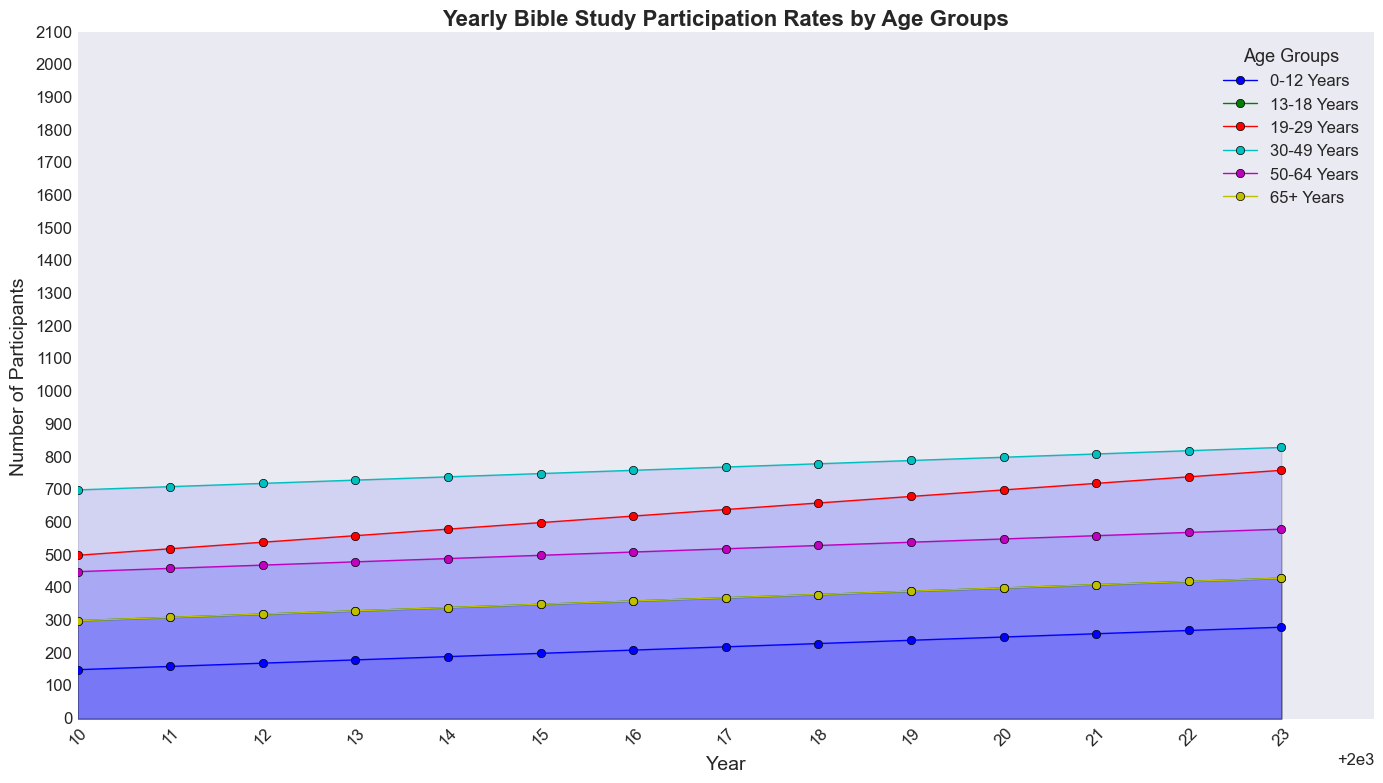what is the overall trend of Bible study participation rates for the 0-12 years age group from 2010 to 2023? By observing the line representing the 0-12 years age group, we note that the number of participants steadily increases each year from 150 in 2010 to 280 in 2023. This indicates a consistent upward trend.
Answer: Upward trend Which age group had the highest number of participants in 2015? By looking at the points in 2015 for all age groups and comparing their heights, we can see that the 30-49 years age group had the highest number of participants.
Answer: 30-49 years Between 2010 and 2023, which two age groups show participation rates increasing by exactly 100 participants? By comparing the participation rates in 2010 and 2023 for each age group: 0-12 years (150 to 280, increase of 130), 13-18 years (300 to 430, increase of 130), 19-29 years (500 to 760, increase of 260), 30-49 years (700 to 830, increase of 130), 50-64 years (450 to 580, increase of 130), 65+ years (300 to 430, increase of 130), and noting that none increased by exactly 100 participants.
Answer: None How do the participation rates of the 19-29 years and 50-64 years age groups compare in 2020? By looking at the heights of the lines in 2020 for both 19-29 years and 50-64 years groups, we note 700 participants for the 19-29 years group, while the 50-64 years group had 550 participants. Thus, the 19-29 years group had higher participation rates.
Answer: 19-29 years had more participants Which age group showed the smallest change in participation rates from 2010 to 2023? By calculating the difference in participation from 2010 to 2023 for each age group: 0-12 years (130), 13-18 years (130), 19-29 years (260), 30-49 years (130), 50-64 years (130), 65+ years (130), the group with the smallest change in participation rates was 0-12 years. As all these differences are the same except for the 19-29 years group, the increased difference is 130.
Answer: 19-29 years In 2015, how much higher is the participation rate for the 30-49 years age group compared to the 50-64 years age group? By observing the points in 2015, the participation rate for the 30-49 years age group is 750, while for the 50-64 years age group it is 500. The difference is 750 - 500 = 250 participants.
Answer: 250 participants What is the average participation rate for the 13-18 years age group over the displayed years? By summing the total participation rates for the 13-18 years group from 2010 to 2023 and dividing by the number of years: (300+310+320+330+340+350+360+370+380+390+400+410+420+430) / 14 = 380.
Answer: 380 